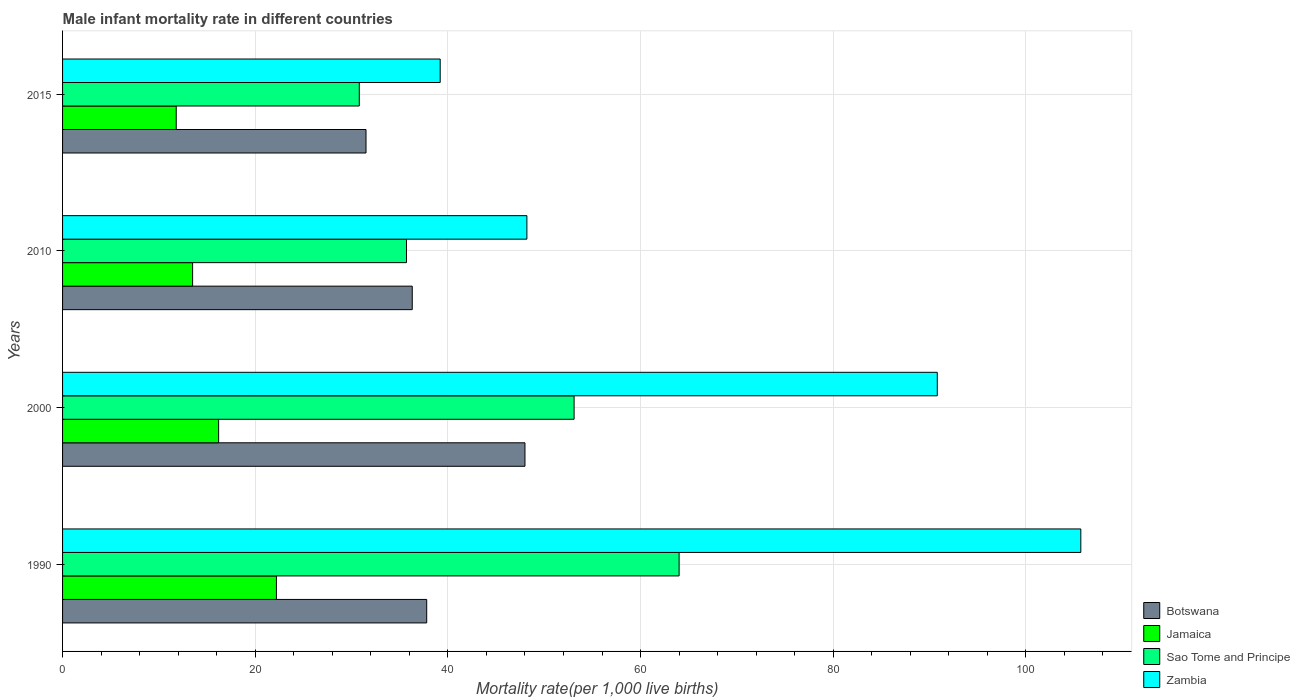How many groups of bars are there?
Offer a terse response. 4. Are the number of bars per tick equal to the number of legend labels?
Provide a short and direct response. Yes. How many bars are there on the 3rd tick from the top?
Offer a terse response. 4. What is the label of the 3rd group of bars from the top?
Your answer should be very brief. 2000. Across all years, what is the minimum male infant mortality rate in Sao Tome and Principe?
Provide a short and direct response. 30.8. In which year was the male infant mortality rate in Jamaica minimum?
Keep it short and to the point. 2015. What is the total male infant mortality rate in Sao Tome and Principe in the graph?
Give a very brief answer. 183.6. What is the difference between the male infant mortality rate in Sao Tome and Principe in 2000 and that in 2010?
Ensure brevity in your answer.  17.4. What is the difference between the male infant mortality rate in Botswana in 1990 and the male infant mortality rate in Zambia in 2015?
Your response must be concise. -1.4. What is the average male infant mortality rate in Zambia per year?
Give a very brief answer. 70.97. In the year 1990, what is the difference between the male infant mortality rate in Zambia and male infant mortality rate in Jamaica?
Offer a very short reply. 83.5. In how many years, is the male infant mortality rate in Botswana greater than 64 ?
Provide a short and direct response. 0. What is the ratio of the male infant mortality rate in Sao Tome and Principe in 1990 to that in 2010?
Your answer should be very brief. 1.79. Is the difference between the male infant mortality rate in Zambia in 2000 and 2015 greater than the difference between the male infant mortality rate in Jamaica in 2000 and 2015?
Keep it short and to the point. Yes. What is the difference between the highest and the second highest male infant mortality rate in Zambia?
Your answer should be very brief. 14.9. What is the difference between the highest and the lowest male infant mortality rate in Sao Tome and Principe?
Offer a very short reply. 33.2. In how many years, is the male infant mortality rate in Zambia greater than the average male infant mortality rate in Zambia taken over all years?
Offer a very short reply. 2. Is the sum of the male infant mortality rate in Jamaica in 1990 and 2000 greater than the maximum male infant mortality rate in Sao Tome and Principe across all years?
Provide a short and direct response. No. What does the 3rd bar from the top in 1990 represents?
Provide a succinct answer. Jamaica. What does the 4th bar from the bottom in 2010 represents?
Ensure brevity in your answer.  Zambia. How many bars are there?
Your response must be concise. 16. How many years are there in the graph?
Offer a very short reply. 4. Does the graph contain grids?
Ensure brevity in your answer.  Yes. How many legend labels are there?
Keep it short and to the point. 4. What is the title of the graph?
Provide a succinct answer. Male infant mortality rate in different countries. Does "South Asia" appear as one of the legend labels in the graph?
Provide a short and direct response. No. What is the label or title of the X-axis?
Your answer should be compact. Mortality rate(per 1,0 live births). What is the label or title of the Y-axis?
Ensure brevity in your answer.  Years. What is the Mortality rate(per 1,000 live births) of Botswana in 1990?
Your answer should be very brief. 37.8. What is the Mortality rate(per 1,000 live births) in Jamaica in 1990?
Your answer should be compact. 22.2. What is the Mortality rate(per 1,000 live births) of Zambia in 1990?
Provide a short and direct response. 105.7. What is the Mortality rate(per 1,000 live births) of Sao Tome and Principe in 2000?
Offer a very short reply. 53.1. What is the Mortality rate(per 1,000 live births) of Zambia in 2000?
Keep it short and to the point. 90.8. What is the Mortality rate(per 1,000 live births) in Botswana in 2010?
Keep it short and to the point. 36.3. What is the Mortality rate(per 1,000 live births) of Sao Tome and Principe in 2010?
Offer a terse response. 35.7. What is the Mortality rate(per 1,000 live births) in Zambia in 2010?
Give a very brief answer. 48.2. What is the Mortality rate(per 1,000 live births) of Botswana in 2015?
Ensure brevity in your answer.  31.5. What is the Mortality rate(per 1,000 live births) in Jamaica in 2015?
Your response must be concise. 11.8. What is the Mortality rate(per 1,000 live births) in Sao Tome and Principe in 2015?
Give a very brief answer. 30.8. What is the Mortality rate(per 1,000 live births) of Zambia in 2015?
Ensure brevity in your answer.  39.2. Across all years, what is the maximum Mortality rate(per 1,000 live births) in Botswana?
Your response must be concise. 48. Across all years, what is the maximum Mortality rate(per 1,000 live births) of Zambia?
Keep it short and to the point. 105.7. Across all years, what is the minimum Mortality rate(per 1,000 live births) of Botswana?
Your answer should be compact. 31.5. Across all years, what is the minimum Mortality rate(per 1,000 live births) in Sao Tome and Principe?
Provide a short and direct response. 30.8. Across all years, what is the minimum Mortality rate(per 1,000 live births) of Zambia?
Offer a terse response. 39.2. What is the total Mortality rate(per 1,000 live births) of Botswana in the graph?
Ensure brevity in your answer.  153.6. What is the total Mortality rate(per 1,000 live births) in Jamaica in the graph?
Offer a very short reply. 63.7. What is the total Mortality rate(per 1,000 live births) of Sao Tome and Principe in the graph?
Make the answer very short. 183.6. What is the total Mortality rate(per 1,000 live births) in Zambia in the graph?
Provide a succinct answer. 283.9. What is the difference between the Mortality rate(per 1,000 live births) in Jamaica in 1990 and that in 2000?
Your answer should be compact. 6. What is the difference between the Mortality rate(per 1,000 live births) of Sao Tome and Principe in 1990 and that in 2000?
Offer a terse response. 10.9. What is the difference between the Mortality rate(per 1,000 live births) in Zambia in 1990 and that in 2000?
Your response must be concise. 14.9. What is the difference between the Mortality rate(per 1,000 live births) of Botswana in 1990 and that in 2010?
Provide a succinct answer. 1.5. What is the difference between the Mortality rate(per 1,000 live births) in Jamaica in 1990 and that in 2010?
Offer a terse response. 8.7. What is the difference between the Mortality rate(per 1,000 live births) in Sao Tome and Principe in 1990 and that in 2010?
Make the answer very short. 28.3. What is the difference between the Mortality rate(per 1,000 live births) in Zambia in 1990 and that in 2010?
Keep it short and to the point. 57.5. What is the difference between the Mortality rate(per 1,000 live births) in Botswana in 1990 and that in 2015?
Ensure brevity in your answer.  6.3. What is the difference between the Mortality rate(per 1,000 live births) in Jamaica in 1990 and that in 2015?
Offer a terse response. 10.4. What is the difference between the Mortality rate(per 1,000 live births) in Sao Tome and Principe in 1990 and that in 2015?
Keep it short and to the point. 33.2. What is the difference between the Mortality rate(per 1,000 live births) of Zambia in 1990 and that in 2015?
Your answer should be compact. 66.5. What is the difference between the Mortality rate(per 1,000 live births) of Sao Tome and Principe in 2000 and that in 2010?
Give a very brief answer. 17.4. What is the difference between the Mortality rate(per 1,000 live births) of Zambia in 2000 and that in 2010?
Make the answer very short. 42.6. What is the difference between the Mortality rate(per 1,000 live births) in Jamaica in 2000 and that in 2015?
Your answer should be compact. 4.4. What is the difference between the Mortality rate(per 1,000 live births) in Sao Tome and Principe in 2000 and that in 2015?
Offer a terse response. 22.3. What is the difference between the Mortality rate(per 1,000 live births) in Zambia in 2000 and that in 2015?
Your answer should be compact. 51.6. What is the difference between the Mortality rate(per 1,000 live births) of Botswana in 2010 and that in 2015?
Give a very brief answer. 4.8. What is the difference between the Mortality rate(per 1,000 live births) of Jamaica in 2010 and that in 2015?
Your answer should be compact. 1.7. What is the difference between the Mortality rate(per 1,000 live births) of Sao Tome and Principe in 2010 and that in 2015?
Ensure brevity in your answer.  4.9. What is the difference between the Mortality rate(per 1,000 live births) in Zambia in 2010 and that in 2015?
Your response must be concise. 9. What is the difference between the Mortality rate(per 1,000 live births) of Botswana in 1990 and the Mortality rate(per 1,000 live births) of Jamaica in 2000?
Your answer should be very brief. 21.6. What is the difference between the Mortality rate(per 1,000 live births) of Botswana in 1990 and the Mortality rate(per 1,000 live births) of Sao Tome and Principe in 2000?
Offer a very short reply. -15.3. What is the difference between the Mortality rate(per 1,000 live births) of Botswana in 1990 and the Mortality rate(per 1,000 live births) of Zambia in 2000?
Your answer should be very brief. -53. What is the difference between the Mortality rate(per 1,000 live births) in Jamaica in 1990 and the Mortality rate(per 1,000 live births) in Sao Tome and Principe in 2000?
Give a very brief answer. -30.9. What is the difference between the Mortality rate(per 1,000 live births) in Jamaica in 1990 and the Mortality rate(per 1,000 live births) in Zambia in 2000?
Make the answer very short. -68.6. What is the difference between the Mortality rate(per 1,000 live births) in Sao Tome and Principe in 1990 and the Mortality rate(per 1,000 live births) in Zambia in 2000?
Provide a short and direct response. -26.8. What is the difference between the Mortality rate(per 1,000 live births) of Botswana in 1990 and the Mortality rate(per 1,000 live births) of Jamaica in 2010?
Offer a terse response. 24.3. What is the difference between the Mortality rate(per 1,000 live births) in Botswana in 1990 and the Mortality rate(per 1,000 live births) in Sao Tome and Principe in 2010?
Make the answer very short. 2.1. What is the difference between the Mortality rate(per 1,000 live births) in Jamaica in 1990 and the Mortality rate(per 1,000 live births) in Sao Tome and Principe in 2010?
Offer a terse response. -13.5. What is the difference between the Mortality rate(per 1,000 live births) of Botswana in 1990 and the Mortality rate(per 1,000 live births) of Jamaica in 2015?
Provide a succinct answer. 26. What is the difference between the Mortality rate(per 1,000 live births) in Botswana in 1990 and the Mortality rate(per 1,000 live births) in Sao Tome and Principe in 2015?
Make the answer very short. 7. What is the difference between the Mortality rate(per 1,000 live births) of Jamaica in 1990 and the Mortality rate(per 1,000 live births) of Sao Tome and Principe in 2015?
Keep it short and to the point. -8.6. What is the difference between the Mortality rate(per 1,000 live births) in Sao Tome and Principe in 1990 and the Mortality rate(per 1,000 live births) in Zambia in 2015?
Keep it short and to the point. 24.8. What is the difference between the Mortality rate(per 1,000 live births) of Botswana in 2000 and the Mortality rate(per 1,000 live births) of Jamaica in 2010?
Your answer should be very brief. 34.5. What is the difference between the Mortality rate(per 1,000 live births) in Jamaica in 2000 and the Mortality rate(per 1,000 live births) in Sao Tome and Principe in 2010?
Provide a succinct answer. -19.5. What is the difference between the Mortality rate(per 1,000 live births) in Jamaica in 2000 and the Mortality rate(per 1,000 live births) in Zambia in 2010?
Make the answer very short. -32. What is the difference between the Mortality rate(per 1,000 live births) of Sao Tome and Principe in 2000 and the Mortality rate(per 1,000 live births) of Zambia in 2010?
Provide a short and direct response. 4.9. What is the difference between the Mortality rate(per 1,000 live births) of Botswana in 2000 and the Mortality rate(per 1,000 live births) of Jamaica in 2015?
Provide a succinct answer. 36.2. What is the difference between the Mortality rate(per 1,000 live births) in Botswana in 2000 and the Mortality rate(per 1,000 live births) in Zambia in 2015?
Your answer should be very brief. 8.8. What is the difference between the Mortality rate(per 1,000 live births) in Jamaica in 2000 and the Mortality rate(per 1,000 live births) in Sao Tome and Principe in 2015?
Give a very brief answer. -14.6. What is the difference between the Mortality rate(per 1,000 live births) of Jamaica in 2000 and the Mortality rate(per 1,000 live births) of Zambia in 2015?
Your answer should be very brief. -23. What is the difference between the Mortality rate(per 1,000 live births) in Botswana in 2010 and the Mortality rate(per 1,000 live births) in Jamaica in 2015?
Offer a terse response. 24.5. What is the difference between the Mortality rate(per 1,000 live births) of Botswana in 2010 and the Mortality rate(per 1,000 live births) of Zambia in 2015?
Your answer should be very brief. -2.9. What is the difference between the Mortality rate(per 1,000 live births) of Jamaica in 2010 and the Mortality rate(per 1,000 live births) of Sao Tome and Principe in 2015?
Give a very brief answer. -17.3. What is the difference between the Mortality rate(per 1,000 live births) in Jamaica in 2010 and the Mortality rate(per 1,000 live births) in Zambia in 2015?
Give a very brief answer. -25.7. What is the difference between the Mortality rate(per 1,000 live births) in Sao Tome and Principe in 2010 and the Mortality rate(per 1,000 live births) in Zambia in 2015?
Offer a terse response. -3.5. What is the average Mortality rate(per 1,000 live births) in Botswana per year?
Give a very brief answer. 38.4. What is the average Mortality rate(per 1,000 live births) of Jamaica per year?
Provide a short and direct response. 15.93. What is the average Mortality rate(per 1,000 live births) of Sao Tome and Principe per year?
Keep it short and to the point. 45.9. What is the average Mortality rate(per 1,000 live births) of Zambia per year?
Your answer should be compact. 70.97. In the year 1990, what is the difference between the Mortality rate(per 1,000 live births) of Botswana and Mortality rate(per 1,000 live births) of Sao Tome and Principe?
Offer a very short reply. -26.2. In the year 1990, what is the difference between the Mortality rate(per 1,000 live births) in Botswana and Mortality rate(per 1,000 live births) in Zambia?
Your response must be concise. -67.9. In the year 1990, what is the difference between the Mortality rate(per 1,000 live births) of Jamaica and Mortality rate(per 1,000 live births) of Sao Tome and Principe?
Offer a terse response. -41.8. In the year 1990, what is the difference between the Mortality rate(per 1,000 live births) in Jamaica and Mortality rate(per 1,000 live births) in Zambia?
Your answer should be very brief. -83.5. In the year 1990, what is the difference between the Mortality rate(per 1,000 live births) in Sao Tome and Principe and Mortality rate(per 1,000 live births) in Zambia?
Ensure brevity in your answer.  -41.7. In the year 2000, what is the difference between the Mortality rate(per 1,000 live births) of Botswana and Mortality rate(per 1,000 live births) of Jamaica?
Offer a very short reply. 31.8. In the year 2000, what is the difference between the Mortality rate(per 1,000 live births) of Botswana and Mortality rate(per 1,000 live births) of Zambia?
Provide a succinct answer. -42.8. In the year 2000, what is the difference between the Mortality rate(per 1,000 live births) in Jamaica and Mortality rate(per 1,000 live births) in Sao Tome and Principe?
Ensure brevity in your answer.  -36.9. In the year 2000, what is the difference between the Mortality rate(per 1,000 live births) of Jamaica and Mortality rate(per 1,000 live births) of Zambia?
Keep it short and to the point. -74.6. In the year 2000, what is the difference between the Mortality rate(per 1,000 live births) of Sao Tome and Principe and Mortality rate(per 1,000 live births) of Zambia?
Offer a terse response. -37.7. In the year 2010, what is the difference between the Mortality rate(per 1,000 live births) of Botswana and Mortality rate(per 1,000 live births) of Jamaica?
Provide a succinct answer. 22.8. In the year 2010, what is the difference between the Mortality rate(per 1,000 live births) of Jamaica and Mortality rate(per 1,000 live births) of Sao Tome and Principe?
Your answer should be very brief. -22.2. In the year 2010, what is the difference between the Mortality rate(per 1,000 live births) in Jamaica and Mortality rate(per 1,000 live births) in Zambia?
Your answer should be compact. -34.7. In the year 2010, what is the difference between the Mortality rate(per 1,000 live births) of Sao Tome and Principe and Mortality rate(per 1,000 live births) of Zambia?
Give a very brief answer. -12.5. In the year 2015, what is the difference between the Mortality rate(per 1,000 live births) in Botswana and Mortality rate(per 1,000 live births) in Zambia?
Your response must be concise. -7.7. In the year 2015, what is the difference between the Mortality rate(per 1,000 live births) of Jamaica and Mortality rate(per 1,000 live births) of Zambia?
Your answer should be very brief. -27.4. In the year 2015, what is the difference between the Mortality rate(per 1,000 live births) of Sao Tome and Principe and Mortality rate(per 1,000 live births) of Zambia?
Offer a terse response. -8.4. What is the ratio of the Mortality rate(per 1,000 live births) of Botswana in 1990 to that in 2000?
Your answer should be very brief. 0.79. What is the ratio of the Mortality rate(per 1,000 live births) of Jamaica in 1990 to that in 2000?
Offer a very short reply. 1.37. What is the ratio of the Mortality rate(per 1,000 live births) of Sao Tome and Principe in 1990 to that in 2000?
Offer a terse response. 1.21. What is the ratio of the Mortality rate(per 1,000 live births) of Zambia in 1990 to that in 2000?
Offer a terse response. 1.16. What is the ratio of the Mortality rate(per 1,000 live births) in Botswana in 1990 to that in 2010?
Offer a very short reply. 1.04. What is the ratio of the Mortality rate(per 1,000 live births) of Jamaica in 1990 to that in 2010?
Your answer should be compact. 1.64. What is the ratio of the Mortality rate(per 1,000 live births) of Sao Tome and Principe in 1990 to that in 2010?
Provide a succinct answer. 1.79. What is the ratio of the Mortality rate(per 1,000 live births) in Zambia in 1990 to that in 2010?
Your answer should be very brief. 2.19. What is the ratio of the Mortality rate(per 1,000 live births) of Jamaica in 1990 to that in 2015?
Provide a succinct answer. 1.88. What is the ratio of the Mortality rate(per 1,000 live births) in Sao Tome and Principe in 1990 to that in 2015?
Offer a terse response. 2.08. What is the ratio of the Mortality rate(per 1,000 live births) of Zambia in 1990 to that in 2015?
Your answer should be compact. 2.7. What is the ratio of the Mortality rate(per 1,000 live births) of Botswana in 2000 to that in 2010?
Give a very brief answer. 1.32. What is the ratio of the Mortality rate(per 1,000 live births) of Sao Tome and Principe in 2000 to that in 2010?
Your answer should be very brief. 1.49. What is the ratio of the Mortality rate(per 1,000 live births) in Zambia in 2000 to that in 2010?
Provide a succinct answer. 1.88. What is the ratio of the Mortality rate(per 1,000 live births) in Botswana in 2000 to that in 2015?
Make the answer very short. 1.52. What is the ratio of the Mortality rate(per 1,000 live births) in Jamaica in 2000 to that in 2015?
Offer a terse response. 1.37. What is the ratio of the Mortality rate(per 1,000 live births) in Sao Tome and Principe in 2000 to that in 2015?
Provide a short and direct response. 1.72. What is the ratio of the Mortality rate(per 1,000 live births) of Zambia in 2000 to that in 2015?
Make the answer very short. 2.32. What is the ratio of the Mortality rate(per 1,000 live births) in Botswana in 2010 to that in 2015?
Ensure brevity in your answer.  1.15. What is the ratio of the Mortality rate(per 1,000 live births) of Jamaica in 2010 to that in 2015?
Your answer should be very brief. 1.14. What is the ratio of the Mortality rate(per 1,000 live births) in Sao Tome and Principe in 2010 to that in 2015?
Offer a terse response. 1.16. What is the ratio of the Mortality rate(per 1,000 live births) of Zambia in 2010 to that in 2015?
Keep it short and to the point. 1.23. What is the difference between the highest and the second highest Mortality rate(per 1,000 live births) in Botswana?
Your response must be concise. 10.2. What is the difference between the highest and the second highest Mortality rate(per 1,000 live births) of Sao Tome and Principe?
Give a very brief answer. 10.9. What is the difference between the highest and the second highest Mortality rate(per 1,000 live births) in Zambia?
Your answer should be very brief. 14.9. What is the difference between the highest and the lowest Mortality rate(per 1,000 live births) of Botswana?
Ensure brevity in your answer.  16.5. What is the difference between the highest and the lowest Mortality rate(per 1,000 live births) of Jamaica?
Your response must be concise. 10.4. What is the difference between the highest and the lowest Mortality rate(per 1,000 live births) in Sao Tome and Principe?
Your response must be concise. 33.2. What is the difference between the highest and the lowest Mortality rate(per 1,000 live births) of Zambia?
Your response must be concise. 66.5. 